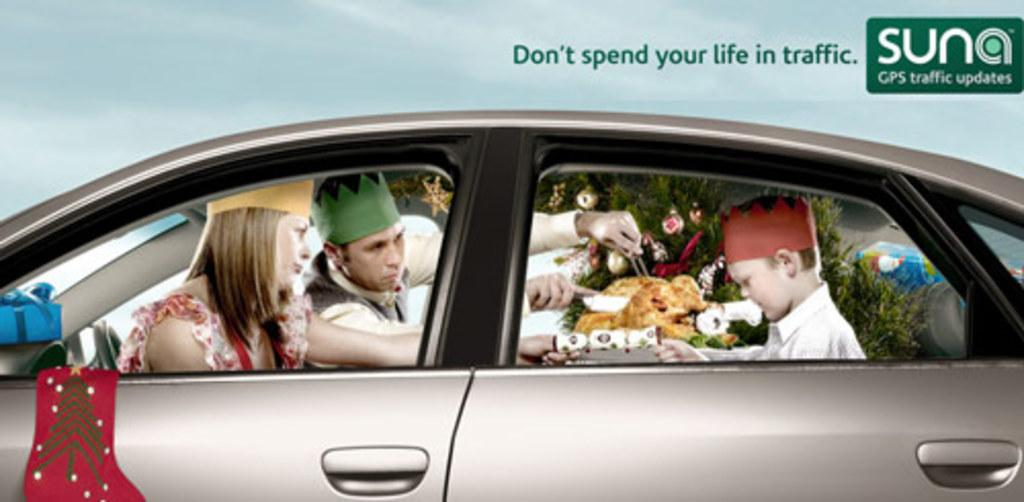What is present on the poster in the image? Unfortunately, the specific details of the poster are not mentioned in the provided facts. However, we can confirm that there is a poster in the image. What are the three persons in the image doing? The three persons are in a car in the image. What type of food can be seen in the image? The provided facts mention that there is food visible in the image, but the specific type of food is not mentioned. What type of ornament is hanging from the rearview mirror in the image? There is no mention of a rearview mirror or any ornament in the provided facts. --- Facts: 1. There is a person holding a book in the image. 2. The person is sitting on a chair. 3. There is a table in the image. 4. The table has a lamp on it. Absurd Topics: parrot, ocean, bicycle Conversation: What is the person in the image holding? The person in the image is holding a book. What is the person's position in the image? The person is sitting on a chair. What object is present on the table in the image? The table has a lamp on it. Reasoning: Let's think step by step in order to produce the conversation. We start by identifying the main subject in the image, which is the person holding a book. Then, we describe the person's position, which is sitting on a chair. Finally, we mention the object present on the table, which is a lamp. Each question is designed to elicit a specific detail about the image that is known from the provided facts. Absurd Question/Answer: Can you see a parrot sitting on the person's shoulder in the image? There is no mention of a parrot in the provided facts. --- Facts: 1. There is a person standing near a tree in the image. 2. The person is holding a camera. 3. The tree has leaves on it. 4. The sky is visible in the image. Absurd Topics: umbrella, rain, fish Conversation: What is the person doing in the image? The person is standing near a tree in the image. What object is the person holding in the image? The person is holding a camera. What can be seen on the tree in the image? The tree has leaves on it. What is visible in the background of the image? The sky is visible in the image. Reasoning: Let's think step by step in order to produce the conversation. We start by identifying the main subject in the image, which is the person standing near a tree. Then, we describe the object the person is holding, which is a camera. Next, we mention the specific feature of the tree, which is the presence 